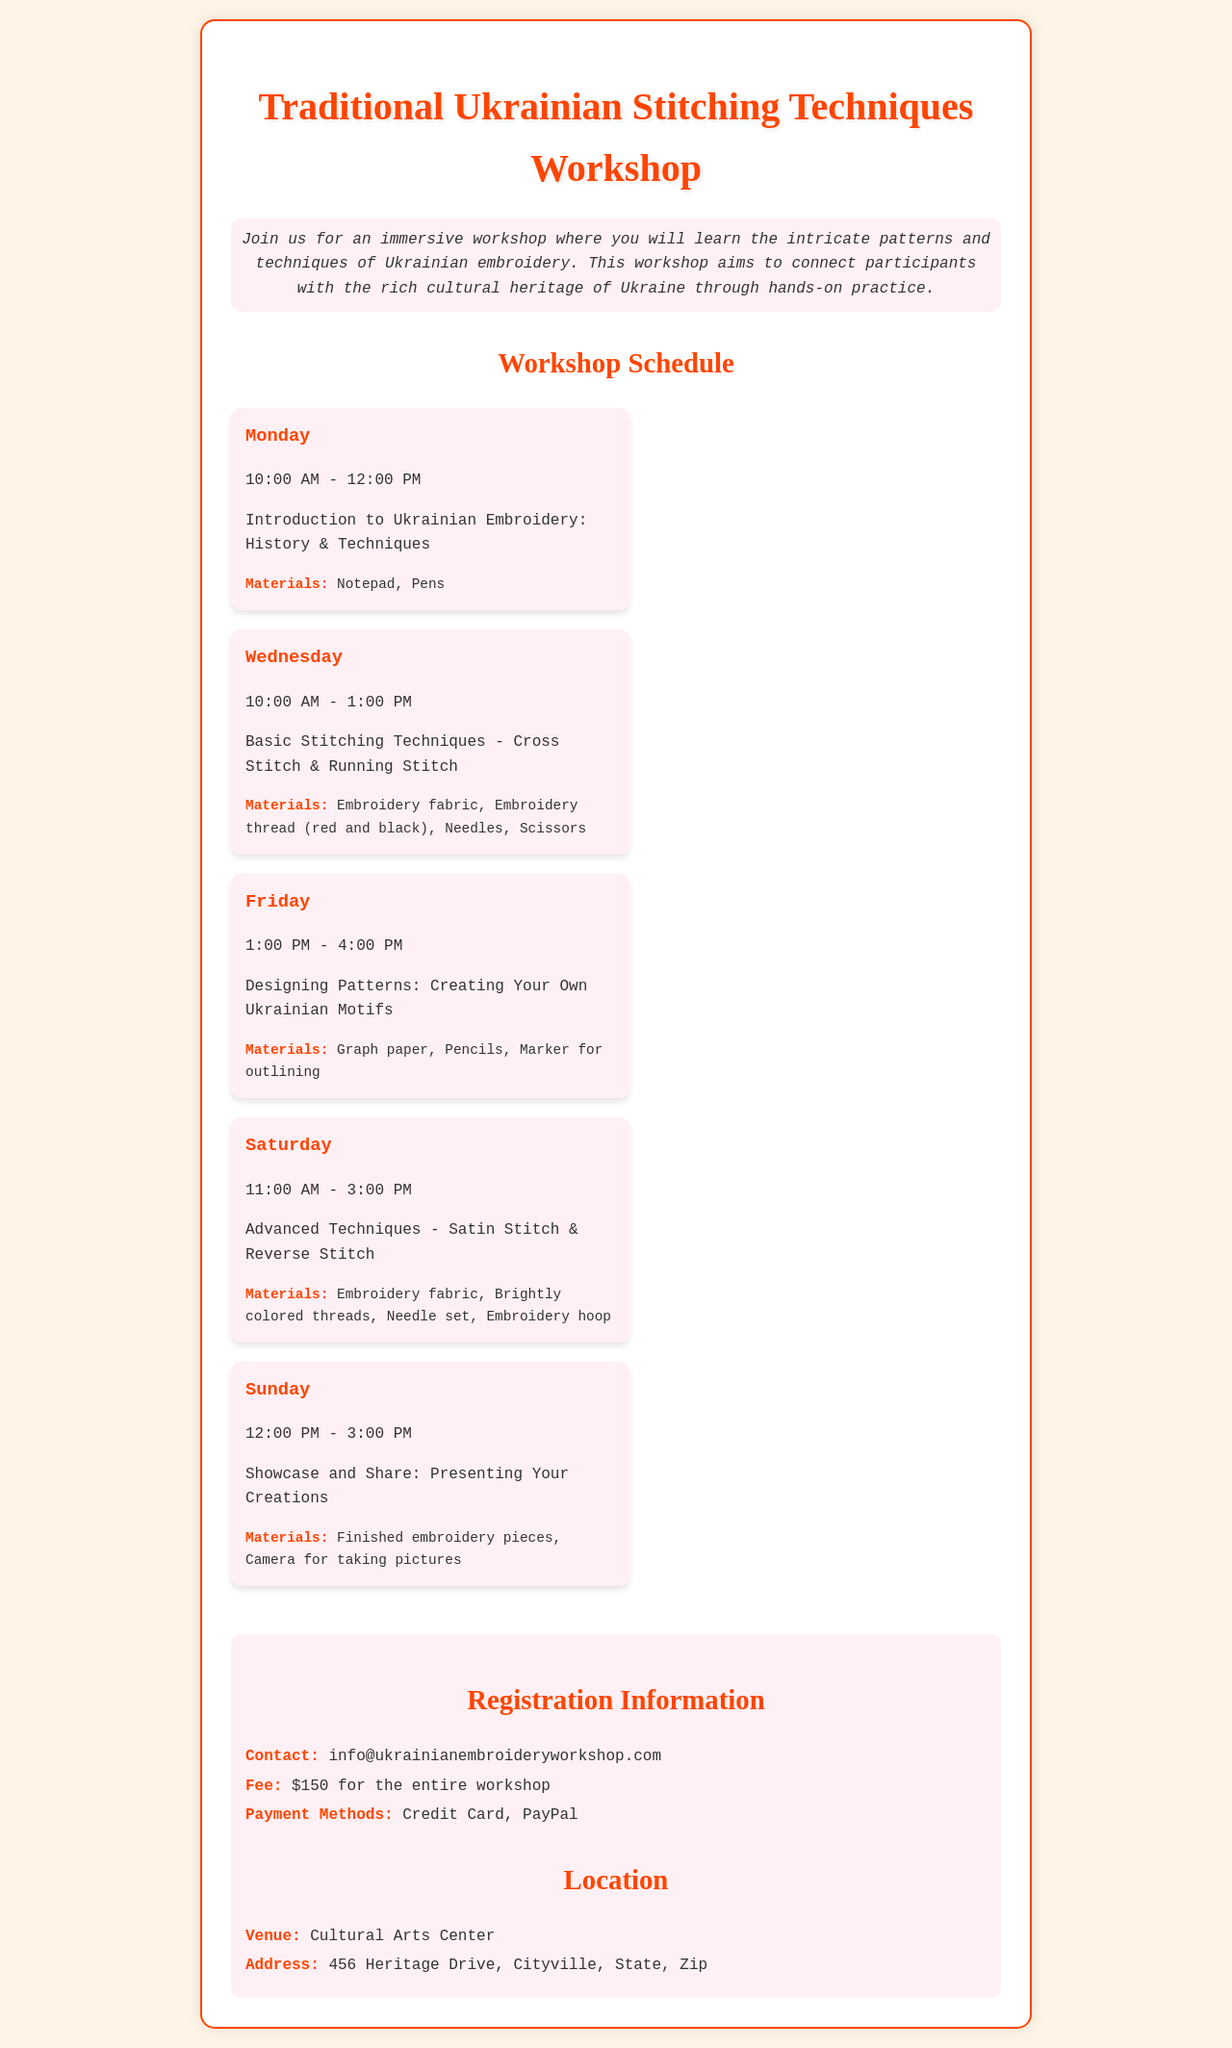What day is the introduction class? The introduction class is on Monday, as detailed in the schedule.
Answer: Monday What is the fee for the entire workshop? The document specifies that the fee for the entire workshop is $150.
Answer: $150 What materials are needed for the advanced techniques class? The advanced techniques class materials are listed in the schedule as brightly colored threads and a needle set.
Answer: Brightly colored threads, Needle set What time does the showcase class start? The showcase class on Sunday starts at 12:00 PM, according to the scheduled times.
Answer: 12:00 PM How many hours is the basic stitching techniques class? The basic stitching techniques class lasts for 3 hours, from 10:00 AM to 1:00 PM.
Answer: 3 hours What is the venue for the workshop? The venue for the workshop is stated in the document as the Cultural Arts Center.
Answer: Cultural Arts Center On which day are participants introduced to history and techniques? Participants are introduced to history and techniques on Monday, based on the schedule provided.
Answer: Monday What payment methods are accepted for the workshop fee? The document lists credit card and PayPal as accepted payment methods.
Answer: Credit Card, PayPal 